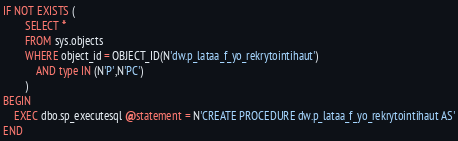<code> <loc_0><loc_0><loc_500><loc_500><_SQL_>IF NOT EXISTS (
		SELECT *
		FROM sys.objects
		WHERE object_id = OBJECT_ID(N'dw.p_lataa_f_yo_rekrytointihaut')
			AND type IN (N'P',N'PC')
		)
BEGIN
	EXEC dbo.sp_executesql @statement = N'CREATE PROCEDURE dw.p_lataa_f_yo_rekrytointihaut AS'
END
</code> 